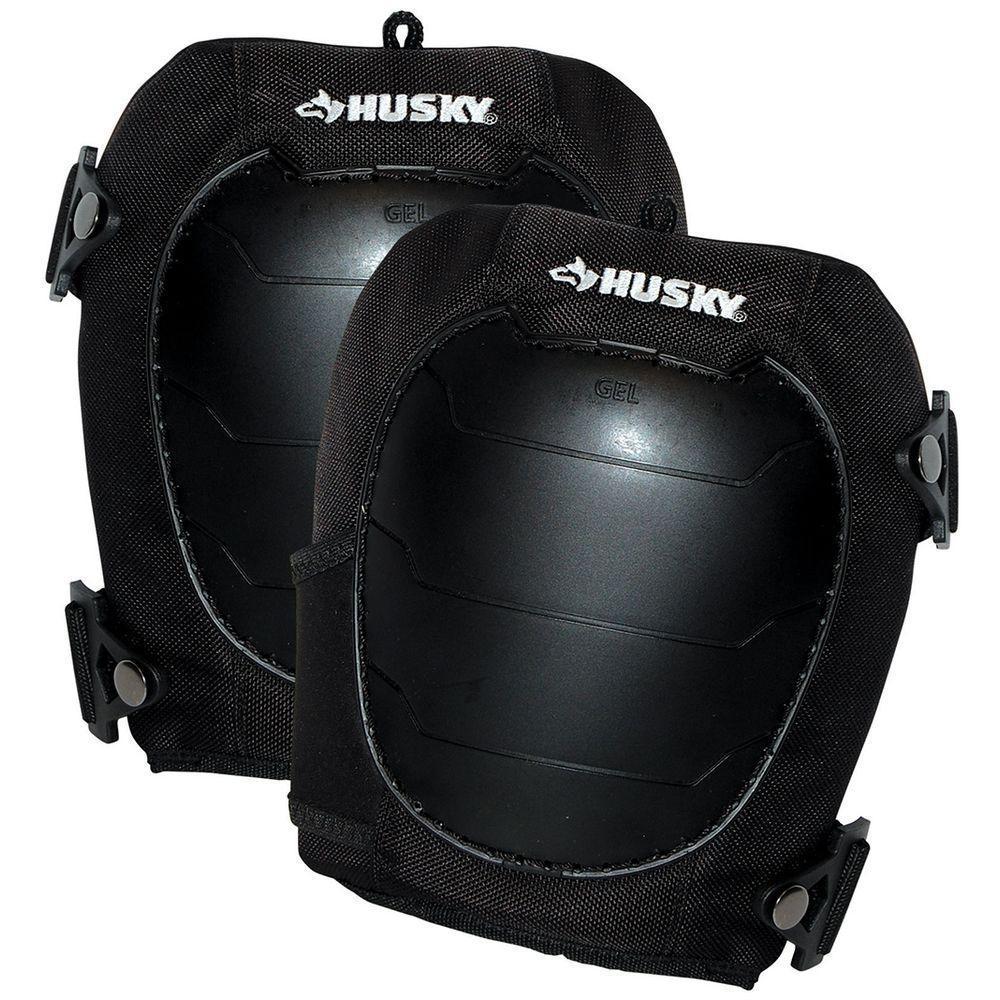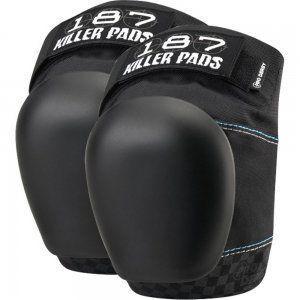The first image is the image on the left, the second image is the image on the right. Analyze the images presented: Is the assertion "Exactly two pairs of knee pads are shown, each solid black with logos, one pair viewed from the front and one at an angle to give a side view." valid? Answer yes or no. Yes. The first image is the image on the left, the second image is the image on the right. Given the left and right images, does the statement "At least one kneepad appears to be worn on a leg, and all kneepads are facing rightwards." hold true? Answer yes or no. No. 